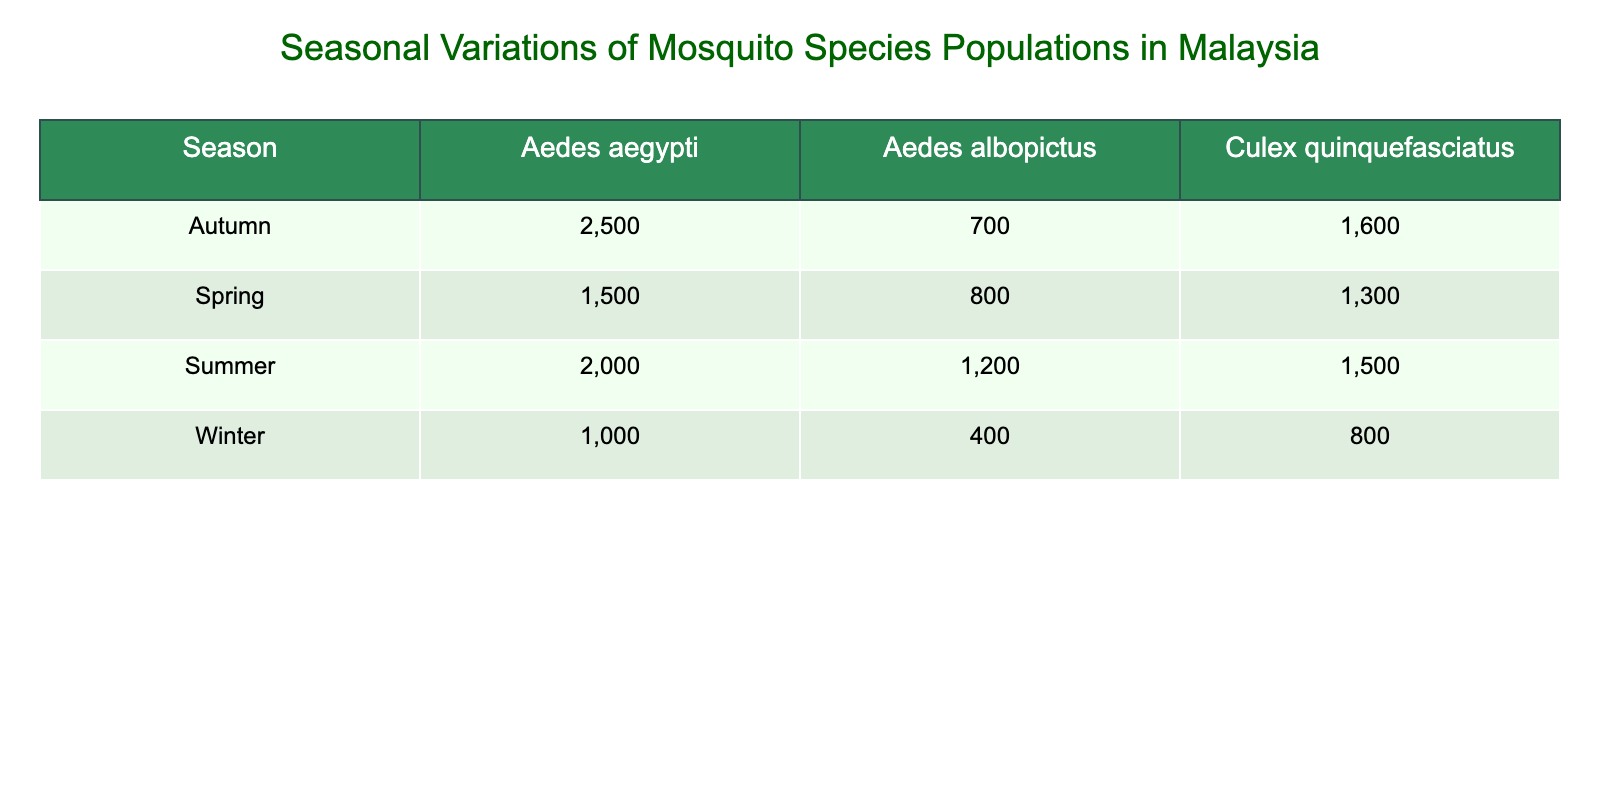What is the population count of Aedes aegypti in Summer? The table lists the population counts by season and mosquito species. In Summer, the population count for Aedes aegypti is found in the corresponding row, which shows 2000.
Answer: 2000 Which mosquito species has the highest population in Autumn? In Autumn, I will compare the population counts for each mosquito species. The counts are 2500 for Aedes aegypti, 700 for Aedes albopictus, and 1600 for Culex quinquefasciatus. The highest count is 2500 for Aedes aegypti.
Answer: Aedes aegypti What is the total population count of Culex quinquefasciatus across all seasons? To find the total for Culex quinquefasciatus, I will sum the counts from all seasons: 1300 (Spring) + 1500 (Summer) + 1600 (Autumn) + 800 (Winter) = 4200.
Answer: 4200 Is the population of Aedes albopictus greater in Summer than in Winter? In Summer, the population of Aedes albopictus is 1200, and in Winter, it is 400. Therefore, 1200 is greater than 400.
Answer: Yes What is the average population count of Aedes albopictus across all seasons? The counts for Aedes albopictus are 800 (Spring), 1200 (Summer), 700 (Autumn), and 400 (Winter). I will sum these values: 800 + 1200 + 700 + 400 = 3100, and then divide by the number of seasons (4): 3100 / 4 = 775.
Answer: 775 Which season has the lowest population count for Aedes albopictus? The counts recorded for Aedes albopictus by season are 800 (Spring), 1200 (Summer), 700 (Autumn), and 400 (Winter). The smallest number, 400, occurs in Winter.
Answer: Winter What is the difference in population counts of Aedes aegypti between Autumn and Winter? In Autumn, Aedes aegypti has a population count of 2500, and in Winter, it has 1000. I will subtract: 2500 - 1000 = 1500.
Answer: 1500 How does the population count of Culex quinquefasciatus compare between Spring and Winter? The population of Culex quinquefasciatus in Spring is 1300, and in Winter, it is 800. Since 1300 is greater than 800, I conclude that Spring has a higher population.
Answer: Spring has a higher population What is the overall trend of Aedes aegypti population counts throughout the seasons? The counts for Aedes aegypti are 1500 (Spring), 2000 (Summer), 2500 (Autumn), and 1000 (Winter). The values increase in Spring, Summer, and Autumn, but then decrease in Winter. Thus, the trend is upward then downward.
Answer: Upward then downward Which mosquito species had the least population in Penang? In Penang, the populations for the species are 800 (Aedes albopictus in Spring), 1200 (Aedes albopictus in Summer), 700 (Aedes albopictus in Autumn), and 400 (Aedes albopictus in Winter). The smallest number is 400 for Winter.
Answer: Aedes albopictus in Winter 